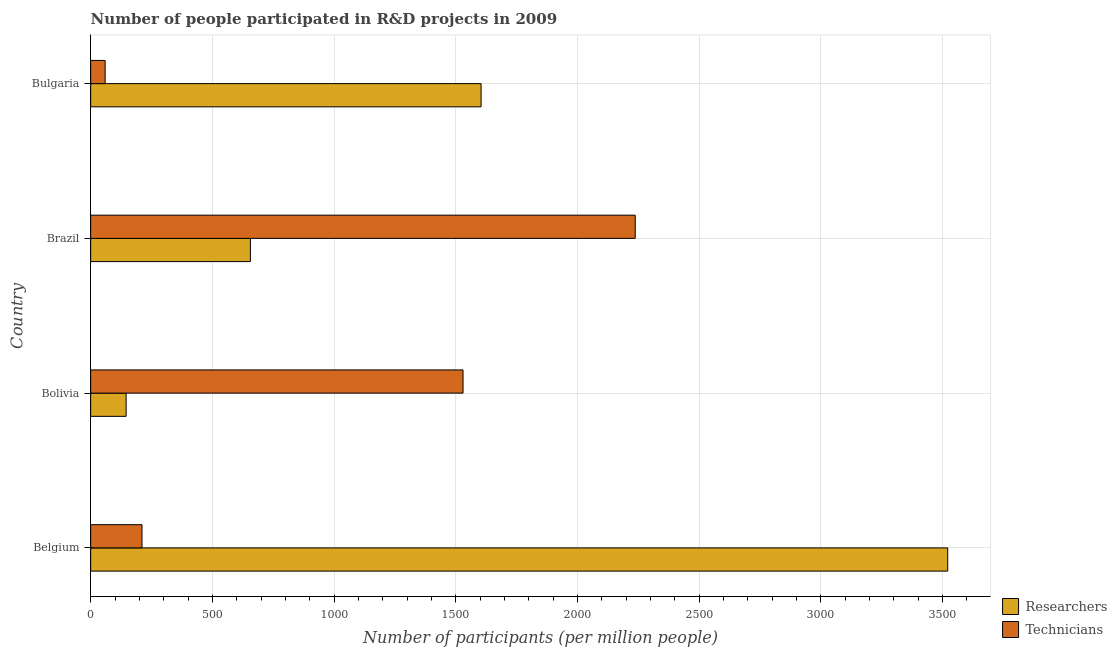How many different coloured bars are there?
Offer a terse response. 2. How many groups of bars are there?
Your answer should be compact. 4. Are the number of bars per tick equal to the number of legend labels?
Your answer should be very brief. Yes. How many bars are there on the 3rd tick from the top?
Your answer should be very brief. 2. What is the number of technicians in Brazil?
Give a very brief answer. 2237.63. Across all countries, what is the maximum number of researchers?
Your answer should be compact. 3521.66. Across all countries, what is the minimum number of researchers?
Ensure brevity in your answer.  145.71. In which country was the number of researchers maximum?
Keep it short and to the point. Belgium. In which country was the number of researchers minimum?
Provide a succinct answer. Bolivia. What is the total number of technicians in the graph?
Provide a succinct answer. 4038.07. What is the difference between the number of technicians in Bolivia and that in Bulgaria?
Provide a succinct answer. 1470.66. What is the difference between the number of researchers in Bulgaria and the number of technicians in Belgium?
Your response must be concise. 1393.36. What is the average number of technicians per country?
Ensure brevity in your answer.  1009.52. What is the difference between the number of researchers and number of technicians in Bolivia?
Ensure brevity in your answer.  -1384.38. In how many countries, is the number of technicians greater than 1700 ?
Offer a very short reply. 1. What is the ratio of the number of researchers in Bolivia to that in Bulgaria?
Your answer should be compact. 0.09. Is the number of researchers in Belgium less than that in Bolivia?
Make the answer very short. No. What is the difference between the highest and the second highest number of technicians?
Provide a succinct answer. 707.53. What is the difference between the highest and the lowest number of researchers?
Make the answer very short. 3375.94. In how many countries, is the number of researchers greater than the average number of researchers taken over all countries?
Make the answer very short. 2. Is the sum of the number of technicians in Belgium and Bolivia greater than the maximum number of researchers across all countries?
Your answer should be very brief. No. What does the 1st bar from the top in Brazil represents?
Your answer should be compact. Technicians. What does the 1st bar from the bottom in Brazil represents?
Your answer should be very brief. Researchers. How many bars are there?
Provide a short and direct response. 8. Does the graph contain any zero values?
Offer a very short reply. No. Where does the legend appear in the graph?
Ensure brevity in your answer.  Bottom right. How many legend labels are there?
Keep it short and to the point. 2. What is the title of the graph?
Keep it short and to the point. Number of people participated in R&D projects in 2009. What is the label or title of the X-axis?
Offer a very short reply. Number of participants (per million people). What is the Number of participants (per million people) in Researchers in Belgium?
Provide a succinct answer. 3521.66. What is the Number of participants (per million people) of Technicians in Belgium?
Offer a very short reply. 210.92. What is the Number of participants (per million people) in Researchers in Bolivia?
Provide a succinct answer. 145.71. What is the Number of participants (per million people) of Technicians in Bolivia?
Ensure brevity in your answer.  1530.09. What is the Number of participants (per million people) in Researchers in Brazil?
Your response must be concise. 656.34. What is the Number of participants (per million people) of Technicians in Brazil?
Make the answer very short. 2237.63. What is the Number of participants (per million people) in Researchers in Bulgaria?
Keep it short and to the point. 1604.28. What is the Number of participants (per million people) of Technicians in Bulgaria?
Offer a terse response. 59.44. Across all countries, what is the maximum Number of participants (per million people) in Researchers?
Offer a very short reply. 3521.66. Across all countries, what is the maximum Number of participants (per million people) of Technicians?
Provide a succinct answer. 2237.63. Across all countries, what is the minimum Number of participants (per million people) of Researchers?
Provide a succinct answer. 145.71. Across all countries, what is the minimum Number of participants (per million people) of Technicians?
Provide a succinct answer. 59.44. What is the total Number of participants (per million people) in Researchers in the graph?
Offer a very short reply. 5927.98. What is the total Number of participants (per million people) in Technicians in the graph?
Your answer should be very brief. 4038.07. What is the difference between the Number of participants (per million people) of Researchers in Belgium and that in Bolivia?
Ensure brevity in your answer.  3375.94. What is the difference between the Number of participants (per million people) in Technicians in Belgium and that in Bolivia?
Keep it short and to the point. -1319.18. What is the difference between the Number of participants (per million people) in Researchers in Belgium and that in Brazil?
Provide a succinct answer. 2865.32. What is the difference between the Number of participants (per million people) in Technicians in Belgium and that in Brazil?
Make the answer very short. -2026.71. What is the difference between the Number of participants (per million people) in Researchers in Belgium and that in Bulgaria?
Your answer should be very brief. 1917.38. What is the difference between the Number of participants (per million people) in Technicians in Belgium and that in Bulgaria?
Your answer should be very brief. 151.48. What is the difference between the Number of participants (per million people) of Researchers in Bolivia and that in Brazil?
Provide a succinct answer. -510.62. What is the difference between the Number of participants (per million people) of Technicians in Bolivia and that in Brazil?
Provide a short and direct response. -707.53. What is the difference between the Number of participants (per million people) in Researchers in Bolivia and that in Bulgaria?
Your response must be concise. -1458.56. What is the difference between the Number of participants (per million people) in Technicians in Bolivia and that in Bulgaria?
Provide a short and direct response. 1470.66. What is the difference between the Number of participants (per million people) in Researchers in Brazil and that in Bulgaria?
Offer a very short reply. -947.94. What is the difference between the Number of participants (per million people) in Technicians in Brazil and that in Bulgaria?
Make the answer very short. 2178.19. What is the difference between the Number of participants (per million people) of Researchers in Belgium and the Number of participants (per million people) of Technicians in Bolivia?
Keep it short and to the point. 1991.56. What is the difference between the Number of participants (per million people) in Researchers in Belgium and the Number of participants (per million people) in Technicians in Brazil?
Provide a short and direct response. 1284.03. What is the difference between the Number of participants (per million people) in Researchers in Belgium and the Number of participants (per million people) in Technicians in Bulgaria?
Your answer should be compact. 3462.22. What is the difference between the Number of participants (per million people) in Researchers in Bolivia and the Number of participants (per million people) in Technicians in Brazil?
Your answer should be very brief. -2091.91. What is the difference between the Number of participants (per million people) of Researchers in Bolivia and the Number of participants (per million people) of Technicians in Bulgaria?
Ensure brevity in your answer.  86.28. What is the difference between the Number of participants (per million people) in Researchers in Brazil and the Number of participants (per million people) in Technicians in Bulgaria?
Keep it short and to the point. 596.9. What is the average Number of participants (per million people) in Researchers per country?
Offer a very short reply. 1482. What is the average Number of participants (per million people) in Technicians per country?
Provide a short and direct response. 1009.52. What is the difference between the Number of participants (per million people) of Researchers and Number of participants (per million people) of Technicians in Belgium?
Provide a succinct answer. 3310.74. What is the difference between the Number of participants (per million people) in Researchers and Number of participants (per million people) in Technicians in Bolivia?
Make the answer very short. -1384.38. What is the difference between the Number of participants (per million people) of Researchers and Number of participants (per million people) of Technicians in Brazil?
Offer a very short reply. -1581.29. What is the difference between the Number of participants (per million people) in Researchers and Number of participants (per million people) in Technicians in Bulgaria?
Your answer should be very brief. 1544.84. What is the ratio of the Number of participants (per million people) of Researchers in Belgium to that in Bolivia?
Offer a terse response. 24.17. What is the ratio of the Number of participants (per million people) of Technicians in Belgium to that in Bolivia?
Your answer should be very brief. 0.14. What is the ratio of the Number of participants (per million people) in Researchers in Belgium to that in Brazil?
Offer a very short reply. 5.37. What is the ratio of the Number of participants (per million people) of Technicians in Belgium to that in Brazil?
Provide a succinct answer. 0.09. What is the ratio of the Number of participants (per million people) in Researchers in Belgium to that in Bulgaria?
Keep it short and to the point. 2.2. What is the ratio of the Number of participants (per million people) of Technicians in Belgium to that in Bulgaria?
Give a very brief answer. 3.55. What is the ratio of the Number of participants (per million people) in Researchers in Bolivia to that in Brazil?
Your answer should be very brief. 0.22. What is the ratio of the Number of participants (per million people) in Technicians in Bolivia to that in Brazil?
Make the answer very short. 0.68. What is the ratio of the Number of participants (per million people) of Researchers in Bolivia to that in Bulgaria?
Make the answer very short. 0.09. What is the ratio of the Number of participants (per million people) in Technicians in Bolivia to that in Bulgaria?
Provide a succinct answer. 25.74. What is the ratio of the Number of participants (per million people) of Researchers in Brazil to that in Bulgaria?
Ensure brevity in your answer.  0.41. What is the ratio of the Number of participants (per million people) in Technicians in Brazil to that in Bulgaria?
Offer a terse response. 37.65. What is the difference between the highest and the second highest Number of participants (per million people) of Researchers?
Your answer should be very brief. 1917.38. What is the difference between the highest and the second highest Number of participants (per million people) in Technicians?
Ensure brevity in your answer.  707.53. What is the difference between the highest and the lowest Number of participants (per million people) in Researchers?
Make the answer very short. 3375.94. What is the difference between the highest and the lowest Number of participants (per million people) of Technicians?
Give a very brief answer. 2178.19. 